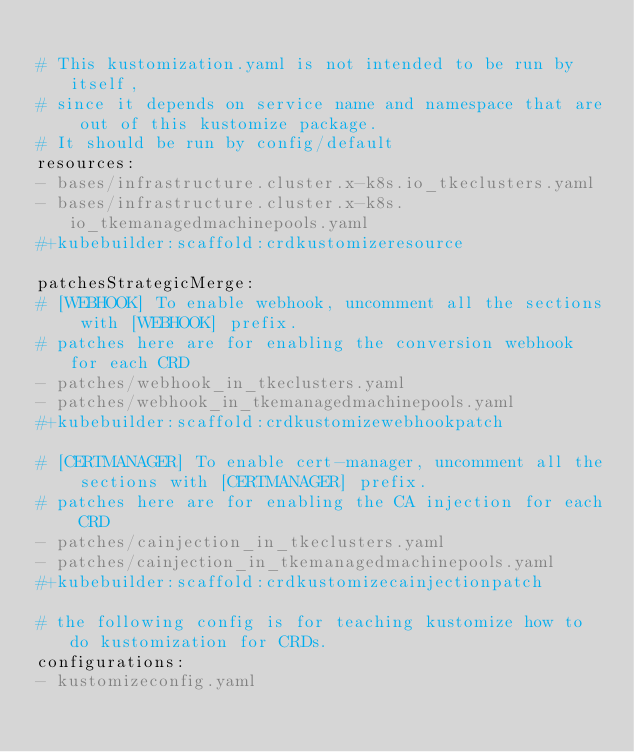<code> <loc_0><loc_0><loc_500><loc_500><_YAML_>
# This kustomization.yaml is not intended to be run by itself,
# since it depends on service name and namespace that are out of this kustomize package.
# It should be run by config/default
resources:
- bases/infrastructure.cluster.x-k8s.io_tkeclusters.yaml
- bases/infrastructure.cluster.x-k8s.io_tkemanagedmachinepools.yaml
#+kubebuilder:scaffold:crdkustomizeresource

patchesStrategicMerge:
# [WEBHOOK] To enable webhook, uncomment all the sections with [WEBHOOK] prefix.
# patches here are for enabling the conversion webhook for each CRD
- patches/webhook_in_tkeclusters.yaml
- patches/webhook_in_tkemanagedmachinepools.yaml
#+kubebuilder:scaffold:crdkustomizewebhookpatch

# [CERTMANAGER] To enable cert-manager, uncomment all the sections with [CERTMANAGER] prefix.
# patches here are for enabling the CA injection for each CRD
- patches/cainjection_in_tkeclusters.yaml
- patches/cainjection_in_tkemanagedmachinepools.yaml
#+kubebuilder:scaffold:crdkustomizecainjectionpatch

# the following config is for teaching kustomize how to do kustomization for CRDs.
configurations:
- kustomizeconfig.yaml
</code> 